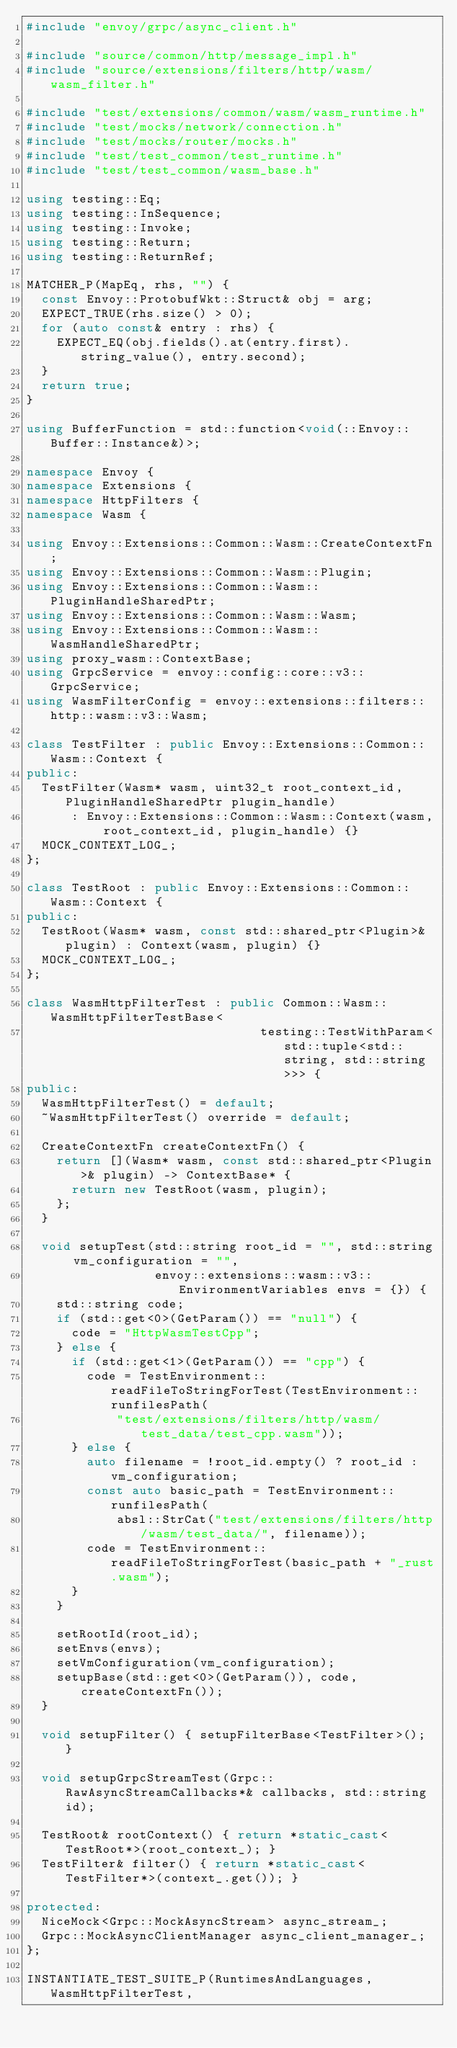<code> <loc_0><loc_0><loc_500><loc_500><_C++_>#include "envoy/grpc/async_client.h"

#include "source/common/http/message_impl.h"
#include "source/extensions/filters/http/wasm/wasm_filter.h"

#include "test/extensions/common/wasm/wasm_runtime.h"
#include "test/mocks/network/connection.h"
#include "test/mocks/router/mocks.h"
#include "test/test_common/test_runtime.h"
#include "test/test_common/wasm_base.h"

using testing::Eq;
using testing::InSequence;
using testing::Invoke;
using testing::Return;
using testing::ReturnRef;

MATCHER_P(MapEq, rhs, "") {
  const Envoy::ProtobufWkt::Struct& obj = arg;
  EXPECT_TRUE(rhs.size() > 0);
  for (auto const& entry : rhs) {
    EXPECT_EQ(obj.fields().at(entry.first).string_value(), entry.second);
  }
  return true;
}

using BufferFunction = std::function<void(::Envoy::Buffer::Instance&)>;

namespace Envoy {
namespace Extensions {
namespace HttpFilters {
namespace Wasm {

using Envoy::Extensions::Common::Wasm::CreateContextFn;
using Envoy::Extensions::Common::Wasm::Plugin;
using Envoy::Extensions::Common::Wasm::PluginHandleSharedPtr;
using Envoy::Extensions::Common::Wasm::Wasm;
using Envoy::Extensions::Common::Wasm::WasmHandleSharedPtr;
using proxy_wasm::ContextBase;
using GrpcService = envoy::config::core::v3::GrpcService;
using WasmFilterConfig = envoy::extensions::filters::http::wasm::v3::Wasm;

class TestFilter : public Envoy::Extensions::Common::Wasm::Context {
public:
  TestFilter(Wasm* wasm, uint32_t root_context_id, PluginHandleSharedPtr plugin_handle)
      : Envoy::Extensions::Common::Wasm::Context(wasm, root_context_id, plugin_handle) {}
  MOCK_CONTEXT_LOG_;
};

class TestRoot : public Envoy::Extensions::Common::Wasm::Context {
public:
  TestRoot(Wasm* wasm, const std::shared_ptr<Plugin>& plugin) : Context(wasm, plugin) {}
  MOCK_CONTEXT_LOG_;
};

class WasmHttpFilterTest : public Common::Wasm::WasmHttpFilterTestBase<
                               testing::TestWithParam<std::tuple<std::string, std::string>>> {
public:
  WasmHttpFilterTest() = default;
  ~WasmHttpFilterTest() override = default;

  CreateContextFn createContextFn() {
    return [](Wasm* wasm, const std::shared_ptr<Plugin>& plugin) -> ContextBase* {
      return new TestRoot(wasm, plugin);
    };
  }

  void setupTest(std::string root_id = "", std::string vm_configuration = "",
                 envoy::extensions::wasm::v3::EnvironmentVariables envs = {}) {
    std::string code;
    if (std::get<0>(GetParam()) == "null") {
      code = "HttpWasmTestCpp";
    } else {
      if (std::get<1>(GetParam()) == "cpp") {
        code = TestEnvironment::readFileToStringForTest(TestEnvironment::runfilesPath(
            "test/extensions/filters/http/wasm/test_data/test_cpp.wasm"));
      } else {
        auto filename = !root_id.empty() ? root_id : vm_configuration;
        const auto basic_path = TestEnvironment::runfilesPath(
            absl::StrCat("test/extensions/filters/http/wasm/test_data/", filename));
        code = TestEnvironment::readFileToStringForTest(basic_path + "_rust.wasm");
      }
    }

    setRootId(root_id);
    setEnvs(envs);
    setVmConfiguration(vm_configuration);
    setupBase(std::get<0>(GetParam()), code, createContextFn());
  }

  void setupFilter() { setupFilterBase<TestFilter>(); }

  void setupGrpcStreamTest(Grpc::RawAsyncStreamCallbacks*& callbacks, std::string id);

  TestRoot& rootContext() { return *static_cast<TestRoot*>(root_context_); }
  TestFilter& filter() { return *static_cast<TestFilter*>(context_.get()); }

protected:
  NiceMock<Grpc::MockAsyncStream> async_stream_;
  Grpc::MockAsyncClientManager async_client_manager_;
};

INSTANTIATE_TEST_SUITE_P(RuntimesAndLanguages, WasmHttpFilterTest,</code> 